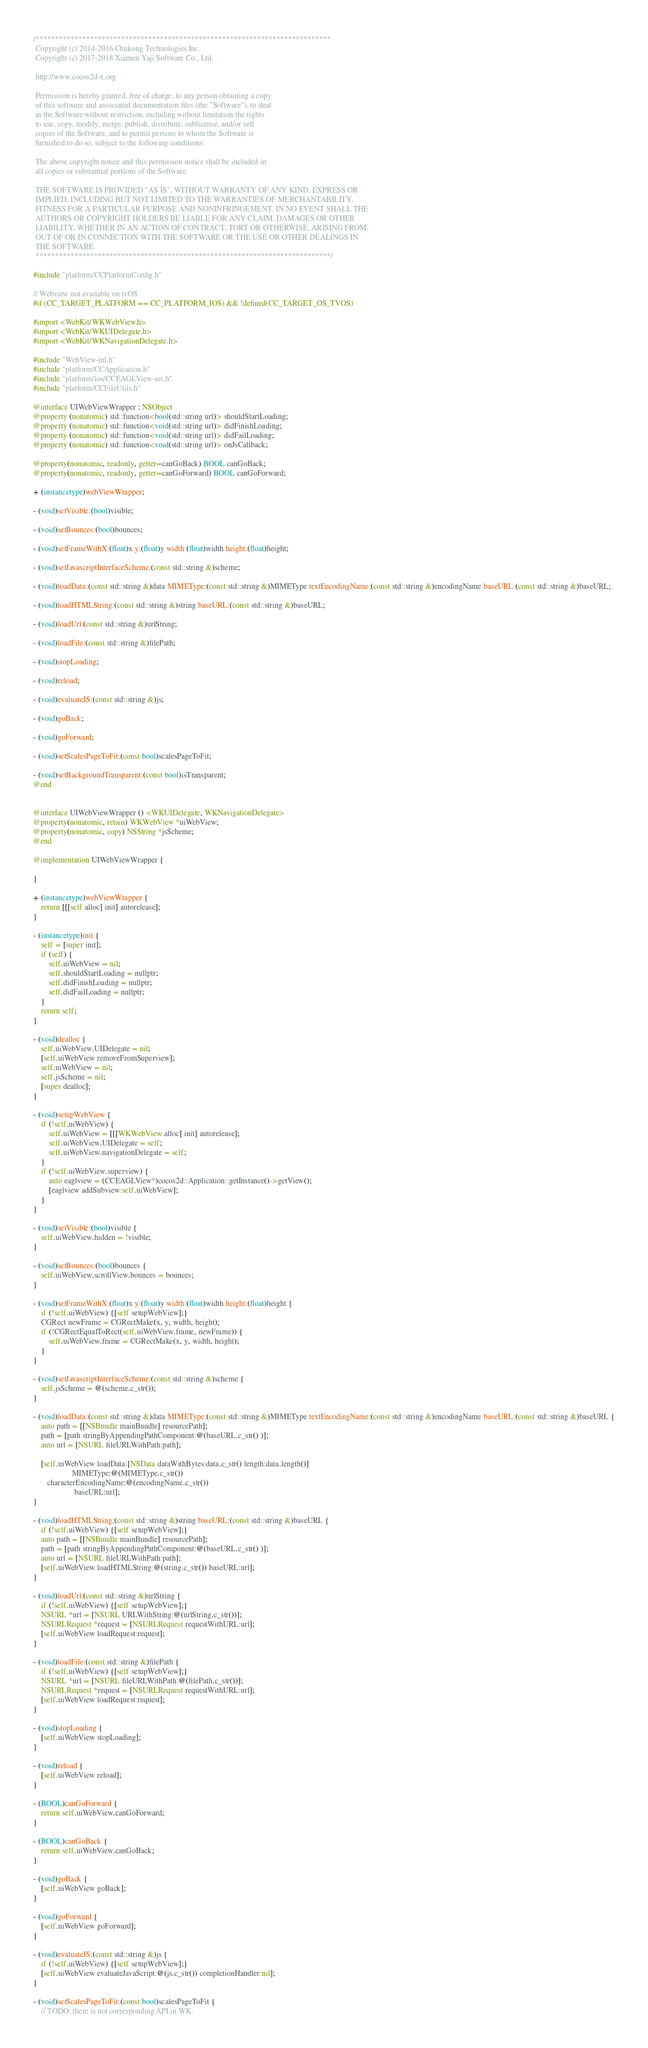<code> <loc_0><loc_0><loc_500><loc_500><_ObjectiveC_>/****************************************************************************
 Copyright (c) 2014-2016 Chukong Technologies Inc.
 Copyright (c) 2017-2018 Xiamen Yaji Software Co., Ltd.

 http://www.cocos2d-x.org

 Permission is hereby granted, free of charge, to any person obtaining a copy
 of this software and associated documentation files (the "Software"), to deal
 in the Software without restriction, including without limitation the rights
 to use, copy, modify, merge, publish, distribute, sublicense, and/or sell
 copies of the Software, and to permit persons to whom the Software is
 furnished to do so, subject to the following conditions:

 The above copyright notice and this permission notice shall be included in
 all copies or substantial portions of the Software.

 THE SOFTWARE IS PROVIDED "AS IS", WITHOUT WARRANTY OF ANY KIND, EXPRESS OR
 IMPLIED, INCLUDING BUT NOT LIMITED TO THE WARRANTIES OF MERCHANTABILITY,
 FITNESS FOR A PARTICULAR PURPOSE AND NONINFRINGEMENT. IN NO EVENT SHALL THE
 AUTHORS OR COPYRIGHT HOLDERS BE LIABLE FOR ANY CLAIM, DAMAGES OR OTHER
 LIABILITY, WHETHER IN AN ACTION OF CONTRACT, TORT OR OTHERWISE, ARISING FROM,
 OUT OF OR IN CONNECTION WITH THE SOFTWARE OR THE USE OR OTHER DEALINGS IN
 THE SOFTWARE.
 ****************************************************************************/

#include "platform/CCPlatformConfig.h"

// Webview not available on tvOS
#if (CC_TARGET_PLATFORM == CC_PLATFORM_IOS) && !defined(CC_TARGET_OS_TVOS)

#import <WebKit/WKWebView.h>
#import <WebKit/WKUIDelegate.h>
#import <WebKit/WKNavigationDelegate.h>

#include "WebView-inl.h"
#include "platform/CCApplication.h"
#include "platform/ios/CCEAGLView-ios.h"
#include "platform/CCFileUtils.h"

@interface UIWebViewWrapper : NSObject
@property (nonatomic) std::function<bool(std::string url)> shouldStartLoading;
@property (nonatomic) std::function<void(std::string url)> didFinishLoading;
@property (nonatomic) std::function<void(std::string url)> didFailLoading;
@property (nonatomic) std::function<void(std::string url)> onJsCallback;

@property(nonatomic, readonly, getter=canGoBack) BOOL canGoBack;
@property(nonatomic, readonly, getter=canGoForward) BOOL canGoForward;

+ (instancetype)webViewWrapper;

- (void)setVisible:(bool)visible;

- (void)setBounces:(bool)bounces;

- (void)setFrameWithX:(float)x y:(float)y width:(float)width height:(float)height;

- (void)setJavascriptInterfaceScheme:(const std::string &)scheme;

- (void)loadData:(const std::string &)data MIMEType:(const std::string &)MIMEType textEncodingName:(const std::string &)encodingName baseURL:(const std::string &)baseURL;

- (void)loadHTMLString:(const std::string &)string baseURL:(const std::string &)baseURL;

- (void)loadUrl:(const std::string &)urlString;

- (void)loadFile:(const std::string &)filePath;

- (void)stopLoading;

- (void)reload;

- (void)evaluateJS:(const std::string &)js;

- (void)goBack;

- (void)goForward;

- (void)setScalesPageToFit:(const bool)scalesPageToFit;

- (void)setBackgroundTransparent:(const bool)isTransparent;
@end


@interface UIWebViewWrapper () <WKUIDelegate, WKNavigationDelegate>
@property(nonatomic, retain) WKWebView *uiWebView;
@property(nonatomic, copy) NSString *jsScheme;
@end

@implementation UIWebViewWrapper {

}

+ (instancetype)webViewWrapper {
    return [[[self alloc] init] autorelease];
}

- (instancetype)init {
    self = [super init];
    if (self) {
        self.uiWebView = nil;
        self.shouldStartLoading = nullptr;
        self.didFinishLoading = nullptr;
        self.didFailLoading = nullptr;
    }
    return self;
}

- (void)dealloc {
    self.uiWebView.UIDelegate = nil;
    [self.uiWebView removeFromSuperview];
    self.uiWebView = nil;
    self.jsScheme = nil;
    [super dealloc];
}

- (void)setupWebView {
    if (!self.uiWebView) {
        self.uiWebView = [[[WKWebView alloc] init] autorelease];
        self.uiWebView.UIDelegate = self;
        self.uiWebView.navigationDelegate = self;
    }
    if (!self.uiWebView.superview) {
        auto eaglview = (CCEAGLView*)cocos2d::Application::getInstance()->getView();
        [eaglview addSubview:self.uiWebView];
    }
}

- (void)setVisible:(bool)visible {
    self.uiWebView.hidden = !visible;
}

- (void)setBounces:(bool)bounces {
    self.uiWebView.scrollView.bounces = bounces;
}

- (void)setFrameWithX:(float)x y:(float)y width:(float)width height:(float)height {
    if (!self.uiWebView) {[self setupWebView];}
    CGRect newFrame = CGRectMake(x, y, width, height);
    if (!CGRectEqualToRect(self.uiWebView.frame, newFrame)) {
        self.uiWebView.frame = CGRectMake(x, y, width, height);
    }
}

- (void)setJavascriptInterfaceScheme:(const std::string &)scheme {
    self.jsScheme = @(scheme.c_str());
}

- (void)loadData:(const std::string &)data MIMEType:(const std::string &)MIMEType textEncodingName:(const std::string &)encodingName baseURL:(const std::string &)baseURL {
    auto path = [[NSBundle mainBundle] resourcePath];
    path = [path stringByAppendingPathComponent:@(baseURL.c_str() )];
    auto url = [NSURL fileURLWithPath:path];

    [self.uiWebView loadData:[NSData dataWithBytes:data.c_str() length:data.length()]
                    MIMEType:@(MIMEType.c_str())
       characterEncodingName:@(encodingName.c_str())
                     baseURL:url];
}

- (void)loadHTMLString:(const std::string &)string baseURL:(const std::string &)baseURL {
    if (!self.uiWebView) {[self setupWebView];}
    auto path = [[NSBundle mainBundle] resourcePath];
    path = [path stringByAppendingPathComponent:@(baseURL.c_str() )];
    auto url = [NSURL fileURLWithPath:path];
    [self.uiWebView loadHTMLString:@(string.c_str()) baseURL:url];
}

- (void)loadUrl:(const std::string &)urlString {
    if (!self.uiWebView) {[self setupWebView];}
    NSURL *url = [NSURL URLWithString:@(urlString.c_str())];
    NSURLRequest *request = [NSURLRequest requestWithURL:url];
    [self.uiWebView loadRequest:request];
}

- (void)loadFile:(const std::string &)filePath {
    if (!self.uiWebView) {[self setupWebView];}
    NSURL *url = [NSURL fileURLWithPath:@(filePath.c_str())];
    NSURLRequest *request = [NSURLRequest requestWithURL:url];
    [self.uiWebView loadRequest:request];
}

- (void)stopLoading {
    [self.uiWebView stopLoading];
}

- (void)reload {
    [self.uiWebView reload];
}

- (BOOL)canGoForward {
    return self.uiWebView.canGoForward;
}

- (BOOL)canGoBack {
    return self.uiWebView.canGoBack;
}

- (void)goBack {
    [self.uiWebView goBack];
}

- (void)goForward {
    [self.uiWebView goForward];
}

- (void)evaluateJS:(const std::string &)js {
    if (!self.uiWebView) {[self setupWebView];}
    [self.uiWebView evaluateJavaScript:@(js.c_str()) completionHandler:nil];
}

- (void)setScalesPageToFit:(const bool)scalesPageToFit {
    // TODO: there is not corresponding API in WK.</code> 